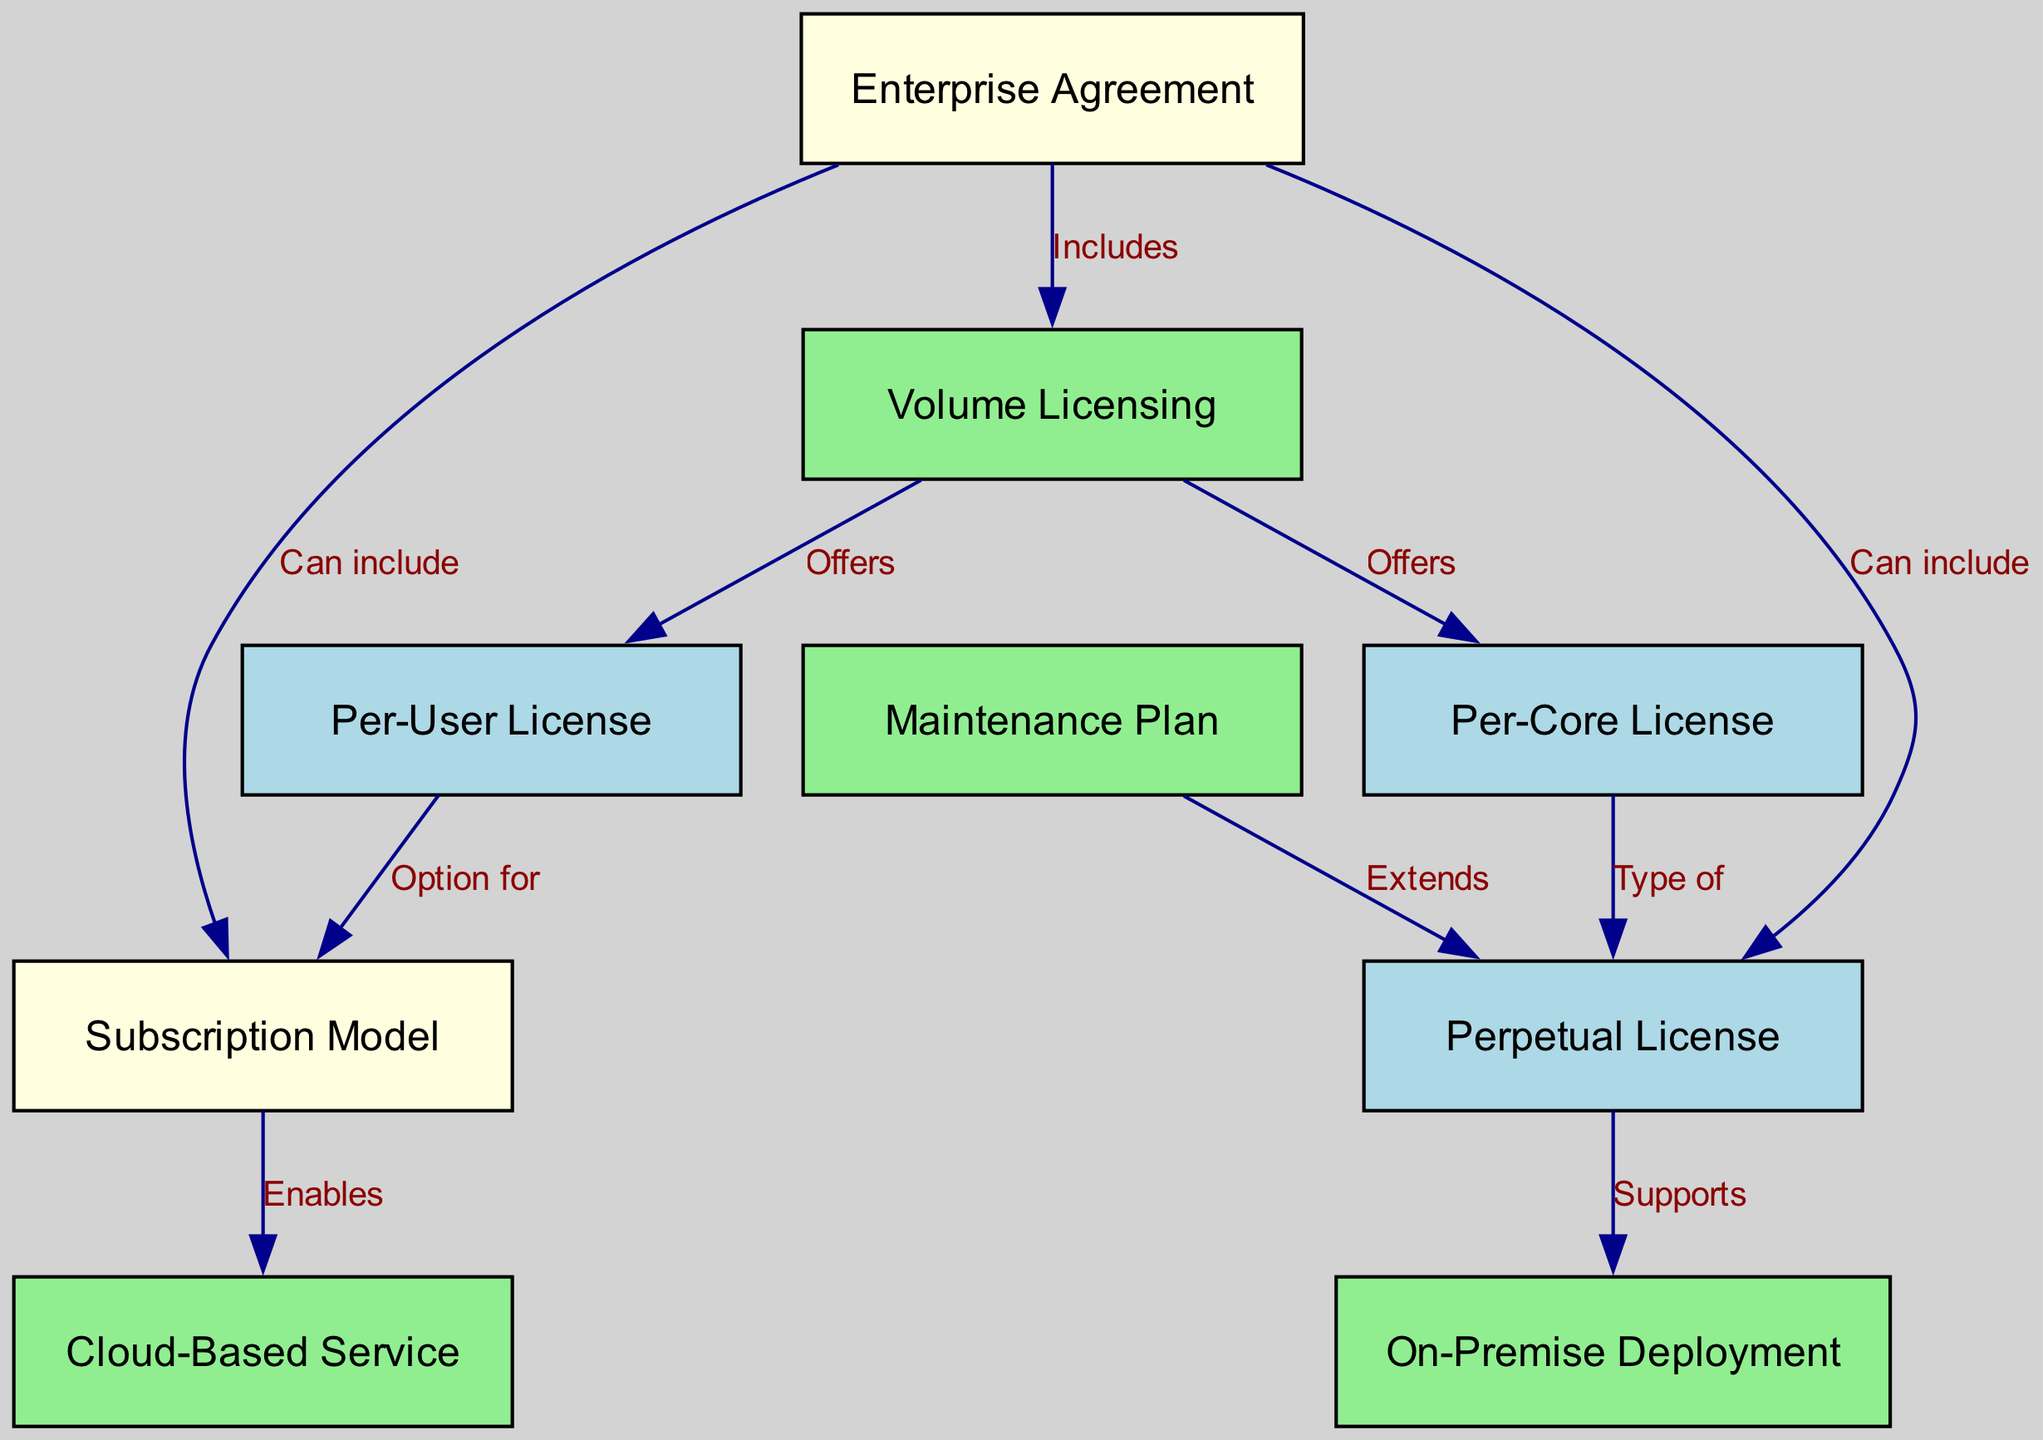What is the total number of nodes in the diagram? The diagram contains the following nodes: "Perpetual License", "Subscription Model", "Enterprise Agreement", "Per-User License", "Per-Core License", "Cloud-Based Service", "On-Premise Deployment", "Volume Licensing", and "Maintenance Plan". Counting these, we find there are a total of 9 nodes.
Answer: 9 Which licensing model includes Volume Licensing? The diagram shows that "Enterprise Agreement" includes "Volume Licensing". The edge labeled "Includes" connects these two nodes, indicating this relationship directly.
Answer: Enterprise Agreement What type of license is a Per-Core License? The edge labeled "Type of" from "Per-Core License" to "Perpetual License" indicates that a Per-Core License is specifically categorized as a type of Perpetual License.
Answer: Perpetual License How many edges are there in total? There are 10 edges in the diagram representing the relationships between different licensing and subscription models. Each edge corresponds to a connection described in the relationships, leading to the final total.
Answer: 10 Which model enables Cloud-Based Service? The edge labeled "Enables" between "Subscription Model" and "Cloud-Based Service" indicates that the Subscription Model enables Cloud-Based Service, establishing this direct connection in the hierarchy.
Answer: Subscription Model What does a Maintenance Plan extend? The connection from "Maintenance Plan" to "Perpetual License" with the label "Extends" indicates that a Maintenance Plan extends the functionality or coverage of a Perpetual License.
Answer: Perpetual License Which two types of licenses does Volume Licensing offer? The edges from "Volume Licensing" to "Per-User License" and "Volume Licensing" to "Per-Core License" demonstrate that Volume Licensing offers both Per-User License and Per-Core License. This involves reviewing both direct connections from the Volume Licensing node.
Answer: Per-User License and Per-Core License What is the relationship between Enterprise Agreement and Subscription Model? The diagram shows an edge labeled "Can include" leading from "Enterprise Agreement" to "Subscription Model". This signifies that an Enterprise Agreement can also include a Subscription Model as part of its offerings, highlighting this multi-faceted relationship.
Answer: Can include What supports the On-Premise Deployment? The "Perpetual License" supports the "On-Premise Deployment" as indicated by the edge labeled "Supports", demonstrating this direct relationship.
Answer: Perpetual License 